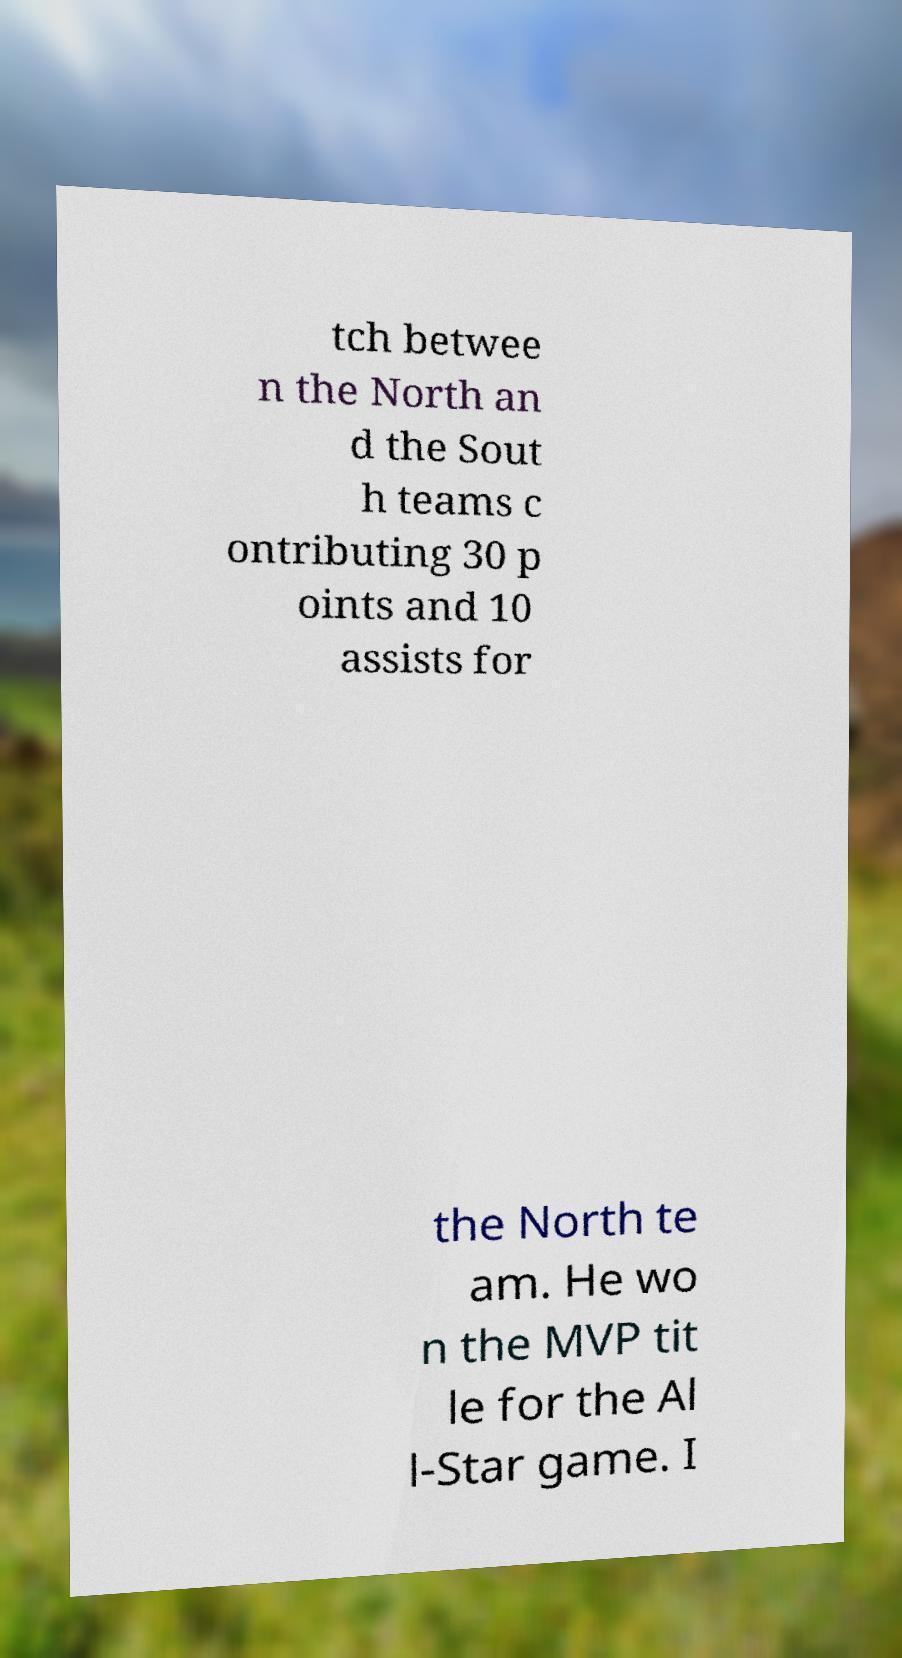Please identify and transcribe the text found in this image. tch betwee n the North an d the Sout h teams c ontributing 30 p oints and 10 assists for the North te am. He wo n the MVP tit le for the Al l-Star game. I 